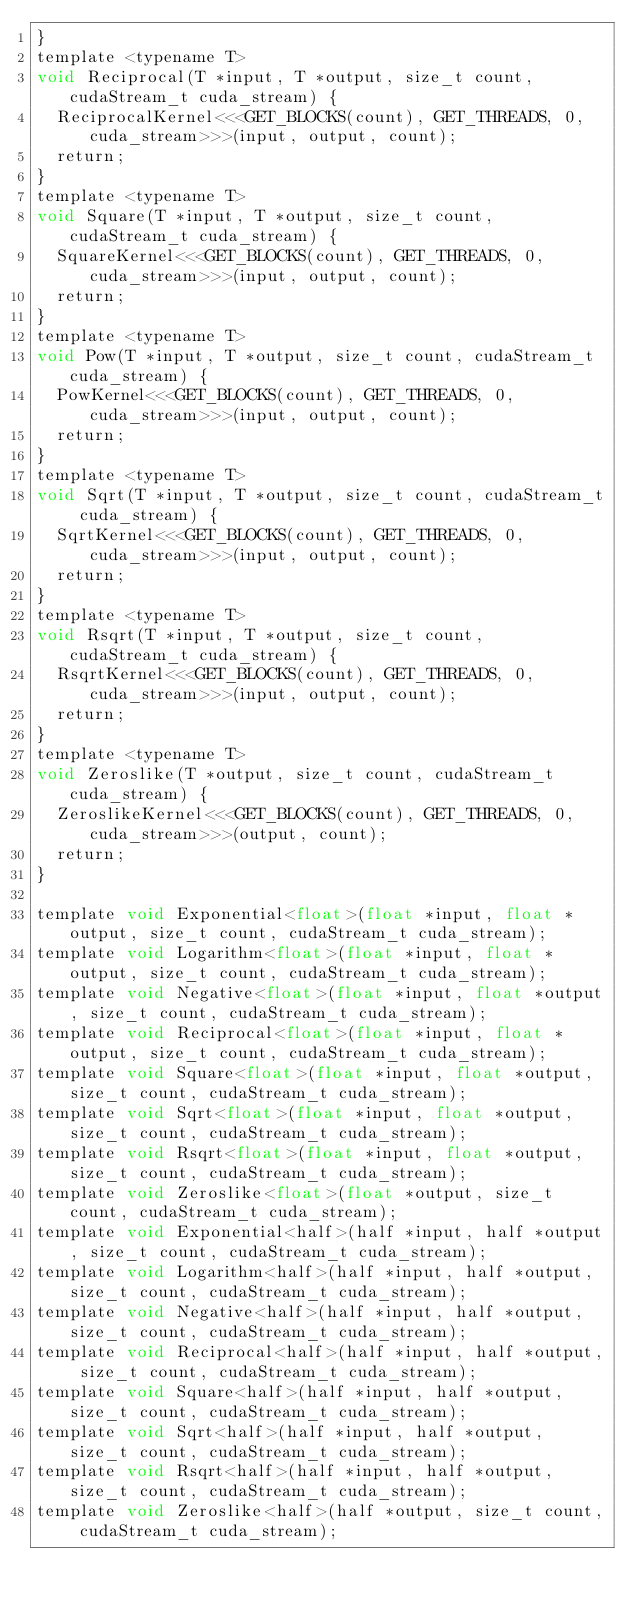Convert code to text. <code><loc_0><loc_0><loc_500><loc_500><_Cuda_>}
template <typename T>
void Reciprocal(T *input, T *output, size_t count, cudaStream_t cuda_stream) {
  ReciprocalKernel<<<GET_BLOCKS(count), GET_THREADS, 0, cuda_stream>>>(input, output, count);
  return;
}
template <typename T>
void Square(T *input, T *output, size_t count, cudaStream_t cuda_stream) {
  SquareKernel<<<GET_BLOCKS(count), GET_THREADS, 0, cuda_stream>>>(input, output, count);
  return;
}
template <typename T>
void Pow(T *input, T *output, size_t count, cudaStream_t cuda_stream) {
  PowKernel<<<GET_BLOCKS(count), GET_THREADS, 0, cuda_stream>>>(input, output, count);
  return;
}
template <typename T>
void Sqrt(T *input, T *output, size_t count, cudaStream_t cuda_stream) {
  SqrtKernel<<<GET_BLOCKS(count), GET_THREADS, 0, cuda_stream>>>(input, output, count);
  return;
}
template <typename T>
void Rsqrt(T *input, T *output, size_t count, cudaStream_t cuda_stream) {
  RsqrtKernel<<<GET_BLOCKS(count), GET_THREADS, 0, cuda_stream>>>(input, output, count);
  return;
}
template <typename T>
void Zeroslike(T *output, size_t count, cudaStream_t cuda_stream) {
  ZeroslikeKernel<<<GET_BLOCKS(count), GET_THREADS, 0, cuda_stream>>>(output, count);
  return;
}

template void Exponential<float>(float *input, float *output, size_t count, cudaStream_t cuda_stream);
template void Logarithm<float>(float *input, float *output, size_t count, cudaStream_t cuda_stream);
template void Negative<float>(float *input, float *output, size_t count, cudaStream_t cuda_stream);
template void Reciprocal<float>(float *input, float *output, size_t count, cudaStream_t cuda_stream);
template void Square<float>(float *input, float *output, size_t count, cudaStream_t cuda_stream);
template void Sqrt<float>(float *input, float *output, size_t count, cudaStream_t cuda_stream);
template void Rsqrt<float>(float *input, float *output, size_t count, cudaStream_t cuda_stream);
template void Zeroslike<float>(float *output, size_t count, cudaStream_t cuda_stream);
template void Exponential<half>(half *input, half *output, size_t count, cudaStream_t cuda_stream);
template void Logarithm<half>(half *input, half *output, size_t count, cudaStream_t cuda_stream);
template void Negative<half>(half *input, half *output, size_t count, cudaStream_t cuda_stream);
template void Reciprocal<half>(half *input, half *output, size_t count, cudaStream_t cuda_stream);
template void Square<half>(half *input, half *output, size_t count, cudaStream_t cuda_stream);
template void Sqrt<half>(half *input, half *output, size_t count, cudaStream_t cuda_stream);
template void Rsqrt<half>(half *input, half *output, size_t count, cudaStream_t cuda_stream);
template void Zeroslike<half>(half *output, size_t count, cudaStream_t cuda_stream);
</code> 